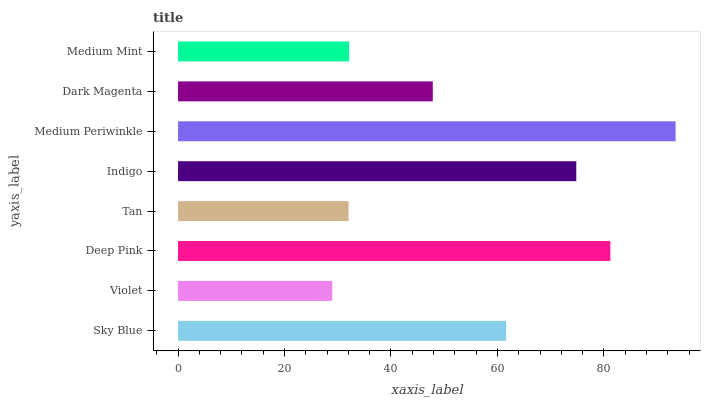Is Violet the minimum?
Answer yes or no. Yes. Is Medium Periwinkle the maximum?
Answer yes or no. Yes. Is Deep Pink the minimum?
Answer yes or no. No. Is Deep Pink the maximum?
Answer yes or no. No. Is Deep Pink greater than Violet?
Answer yes or no. Yes. Is Violet less than Deep Pink?
Answer yes or no. Yes. Is Violet greater than Deep Pink?
Answer yes or no. No. Is Deep Pink less than Violet?
Answer yes or no. No. Is Sky Blue the high median?
Answer yes or no. Yes. Is Dark Magenta the low median?
Answer yes or no. Yes. Is Tan the high median?
Answer yes or no. No. Is Tan the low median?
Answer yes or no. No. 